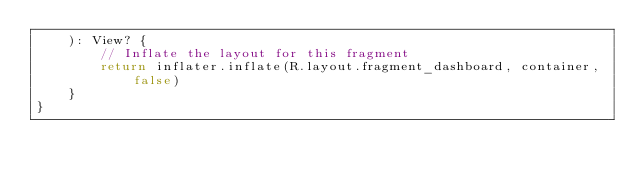<code> <loc_0><loc_0><loc_500><loc_500><_Kotlin_>    ): View? {
        // Inflate the layout for this fragment
        return inflater.inflate(R.layout.fragment_dashboard, container, false)
    }
}
</code> 